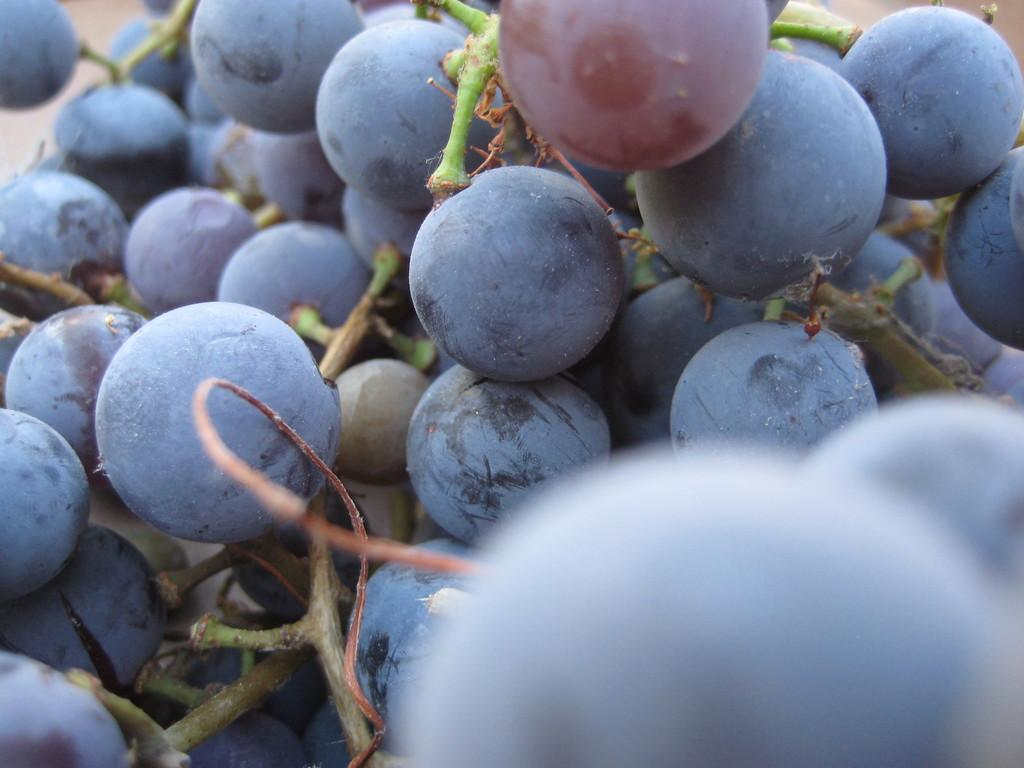What type of fruit is present in the image? There are grapes in the image. What color are the grapes? The grapes are black in color. Can you tell me how many toes the grape expert has in the image? There is no grape expert or mention of toes in the image; it only features black grapes. 